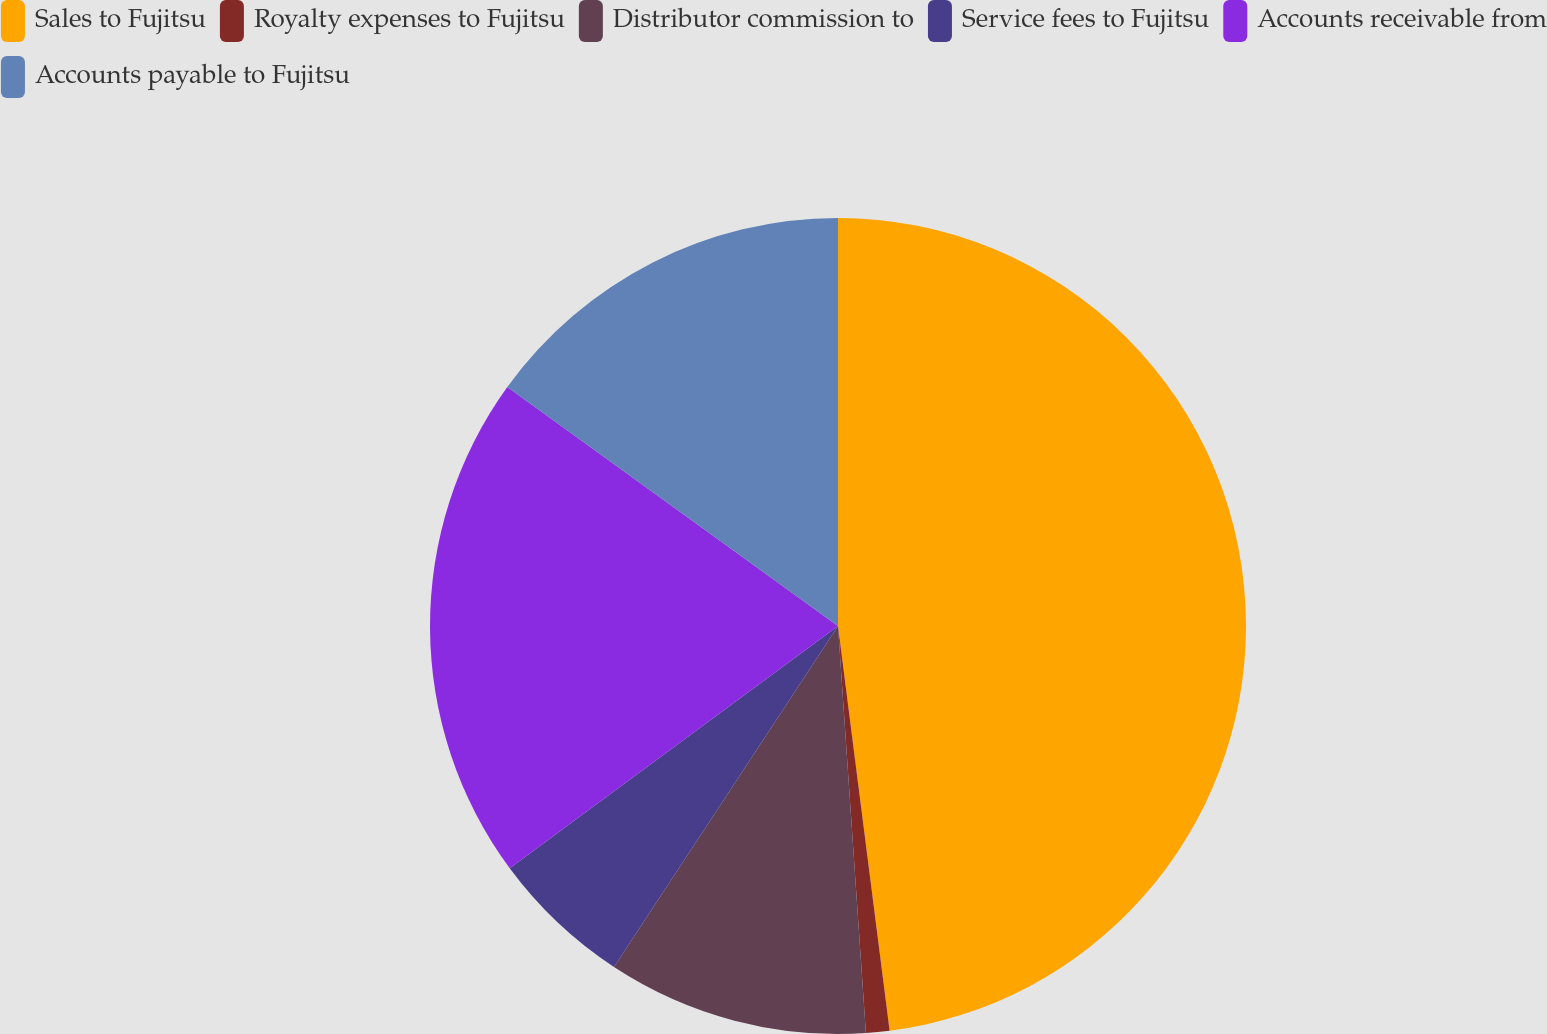<chart> <loc_0><loc_0><loc_500><loc_500><pie_chart><fcel>Sales to Fujitsu<fcel>Royalty expenses to Fujitsu<fcel>Distributor commission to<fcel>Service fees to Fujitsu<fcel>Accounts receivable from<fcel>Accounts payable to Fujitsu<nl><fcel>47.98%<fcel>0.93%<fcel>10.34%<fcel>5.63%<fcel>20.08%<fcel>15.04%<nl></chart> 